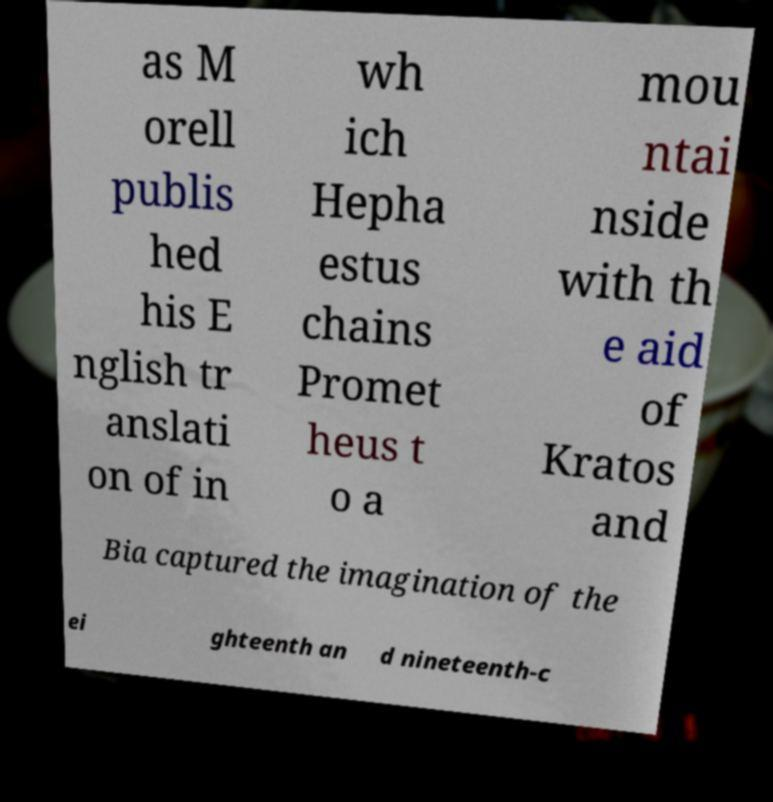Could you assist in decoding the text presented in this image and type it out clearly? as M orell publis hed his E nglish tr anslati on of in wh ich Hepha estus chains Promet heus t o a mou ntai nside with th e aid of Kratos and Bia captured the imagination of the ei ghteenth an d nineteenth-c 